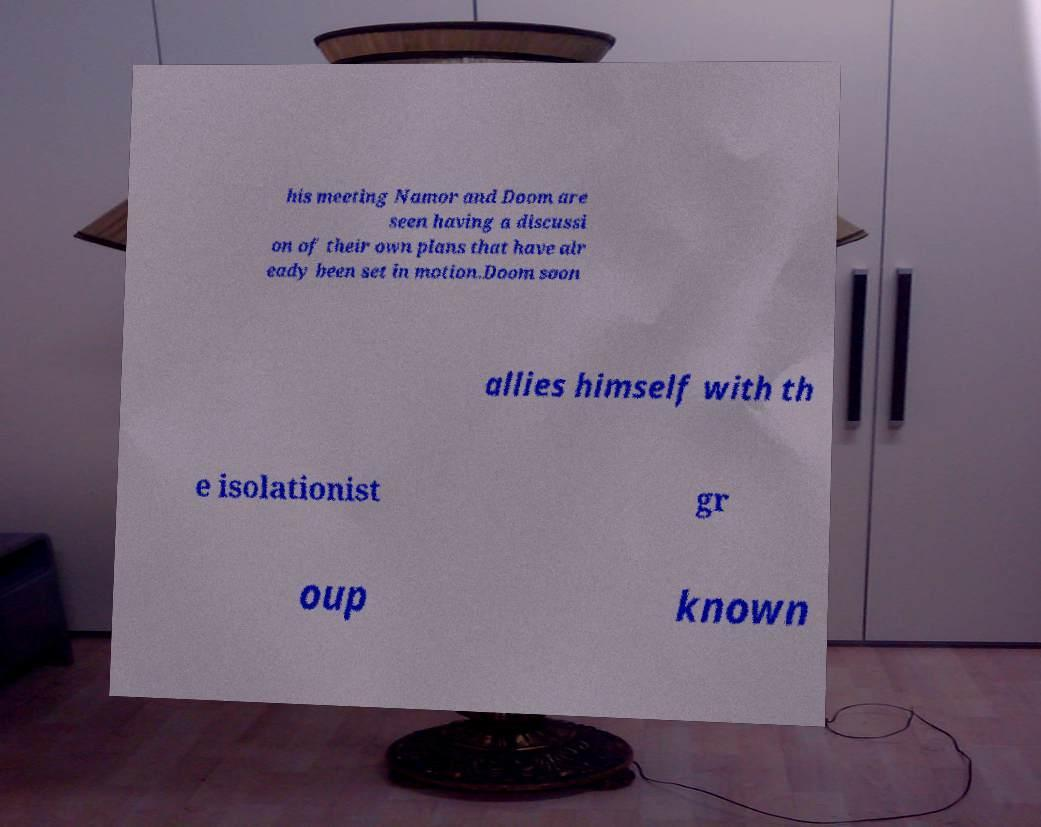Please read and relay the text visible in this image. What does it say? his meeting Namor and Doom are seen having a discussi on of their own plans that have alr eady been set in motion.Doom soon allies himself with th e isolationist gr oup known 